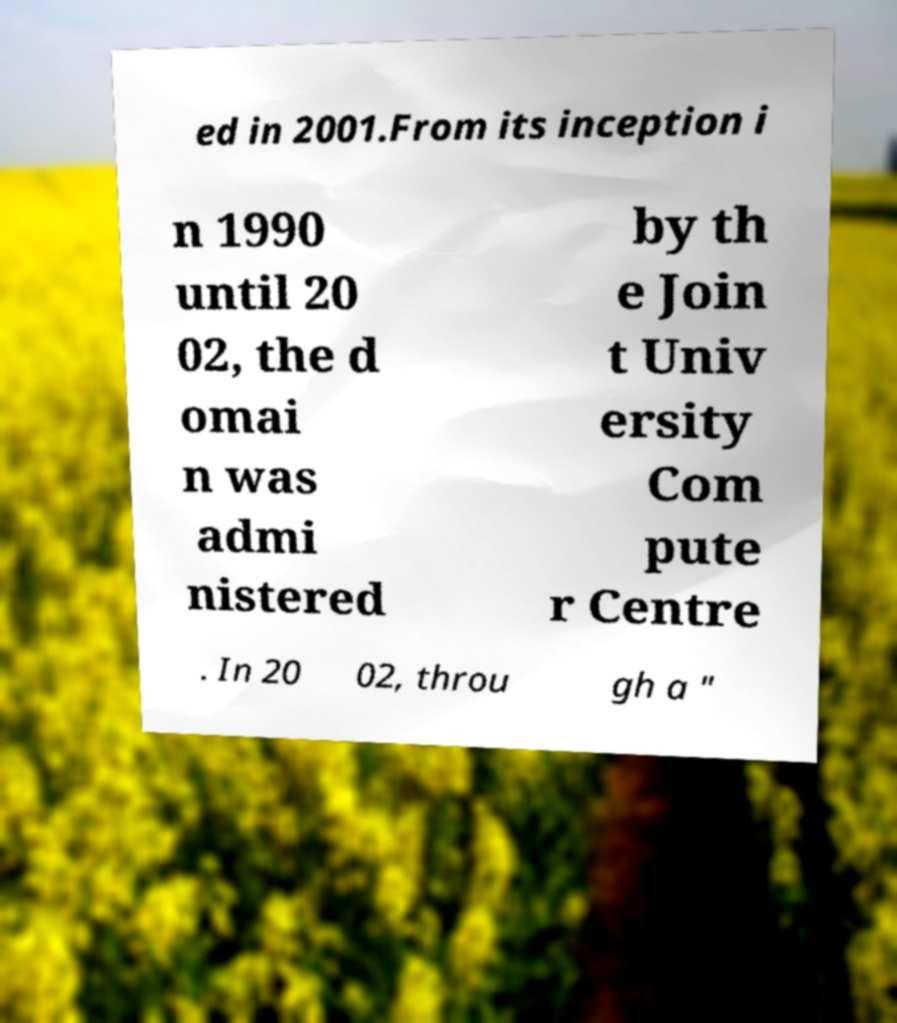Please identify and transcribe the text found in this image. ed in 2001.From its inception i n 1990 until 20 02, the d omai n was admi nistered by th e Join t Univ ersity Com pute r Centre . In 20 02, throu gh a " 